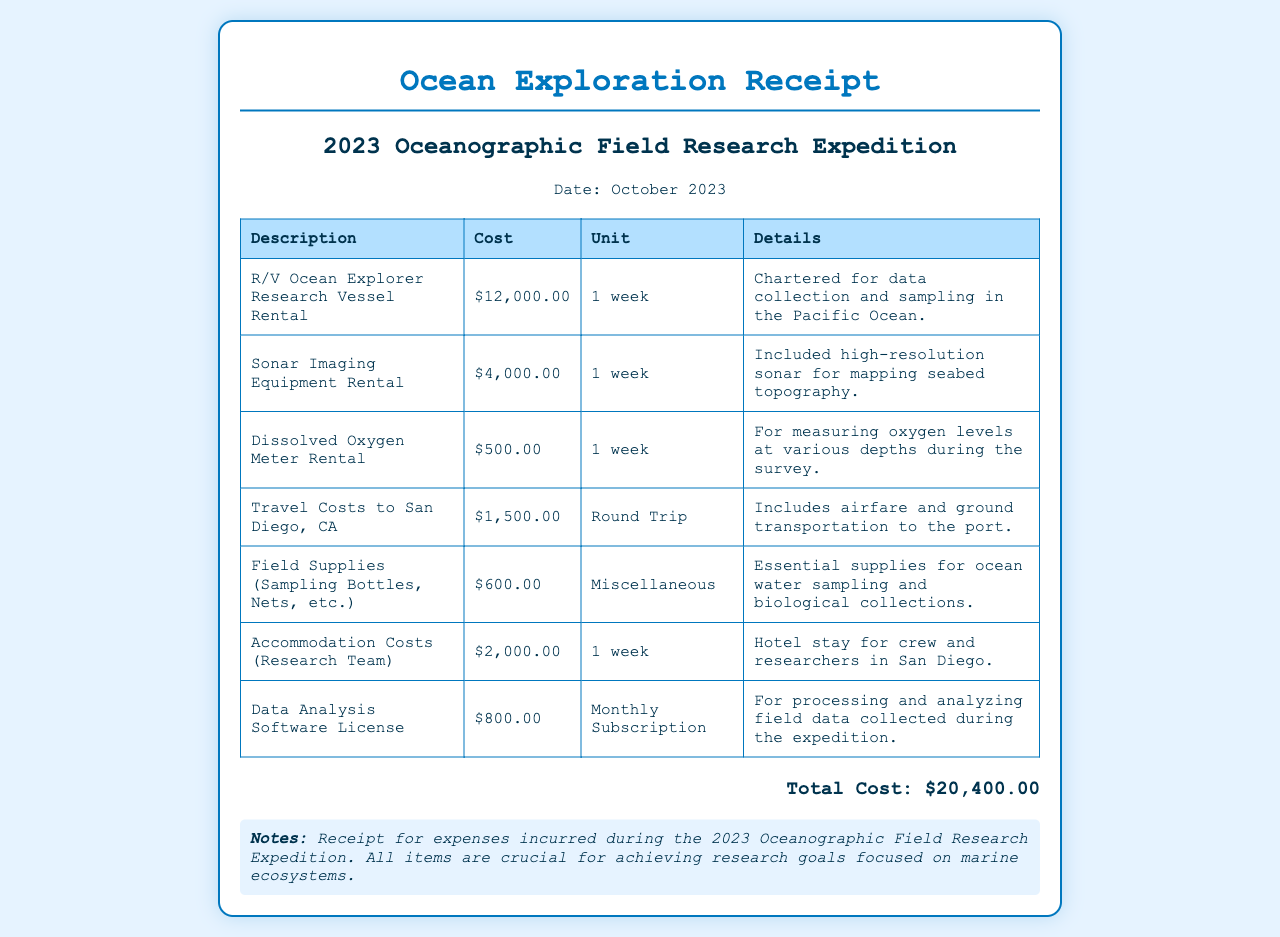What is the title of the receipt? The title identifies the purpose of the document, which is an Ocean Exploration Receipt.
Answer: Ocean Exploration Receipt What is the total cost of the expedition? The total cost is the sum of all itemized expenses listed in the receipt, which amounts to $20,400.00.
Answer: $20,400.00 How much was spent on the research vessel rental? The rental cost for the research vessel is specifically listed as $12,000.00 in the document.
Answer: $12,000.00 What was the cost of travel to San Diego? The travel costs listed for transportation to San Diego are $1,500.00.
Answer: $1,500.00 How long was the research vessel rented? The rental duration for the research vessel is explicitly stated as 1 week.
Answer: 1 week What items were considered field supplies? Field supplies include sampling bottles, nets, and other essentials needed for the expedition.
Answer: Sampling Bottles, Nets, etc What was the purpose of the data analysis software license? The software license was for processing and analyzing field data collected during the expedition.
Answer: Processing and analyzing field data How many types of rental equipment are listed? The receipt specifies three different types of rental equipment for the expedition.
Answer: Three What is noted about the significance of the expenses? The notes emphasize that all items are crucial for achieving research goals focused on marine ecosystems.
Answer: Crucial for achieving research goals 